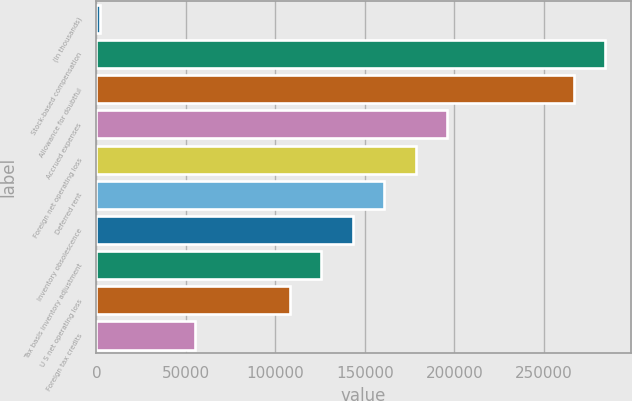<chart> <loc_0><loc_0><loc_500><loc_500><bar_chart><fcel>(In thousands)<fcel>Stock-based compensation<fcel>Allowance for doubtful<fcel>Accrued expenses<fcel>Foreign net operating loss<fcel>Deferred rent<fcel>Inventory obsolescence<fcel>Tax basis inventory adjustment<fcel>U S net operating loss<fcel>Foreign tax credits<nl><fcel>2015<fcel>284474<fcel>266820<fcel>196206<fcel>178552<fcel>160898<fcel>143245<fcel>125591<fcel>107937<fcel>54976.1<nl></chart> 